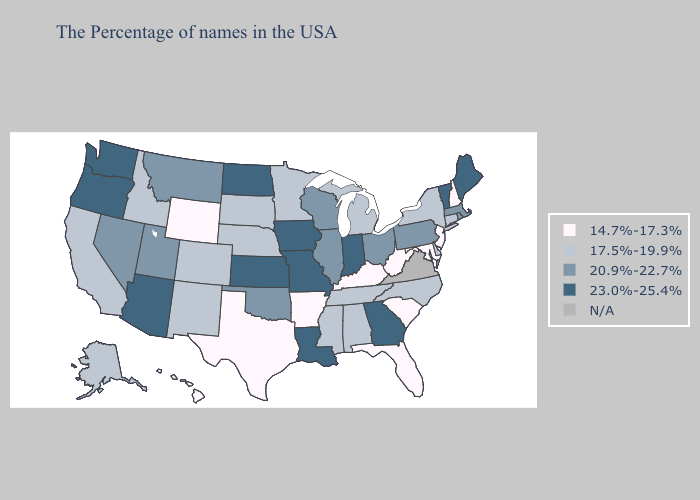Name the states that have a value in the range 14.7%-17.3%?
Concise answer only. New Hampshire, New Jersey, Maryland, South Carolina, West Virginia, Florida, Kentucky, Arkansas, Texas, Wyoming, Hawaii. Does Rhode Island have the highest value in the Northeast?
Answer briefly. No. Among the states that border Florida , does Alabama have the highest value?
Answer briefly. No. Name the states that have a value in the range 17.5%-19.9%?
Quick response, please. Connecticut, New York, Delaware, North Carolina, Michigan, Alabama, Tennessee, Mississippi, Minnesota, Nebraska, South Dakota, Colorado, New Mexico, Idaho, California, Alaska. How many symbols are there in the legend?
Short answer required. 5. Which states have the lowest value in the USA?
Be succinct. New Hampshire, New Jersey, Maryland, South Carolina, West Virginia, Florida, Kentucky, Arkansas, Texas, Wyoming, Hawaii. What is the highest value in the MidWest ?
Be succinct. 23.0%-25.4%. What is the highest value in the USA?
Short answer required. 23.0%-25.4%. What is the value of Connecticut?
Give a very brief answer. 17.5%-19.9%. Which states have the lowest value in the West?
Give a very brief answer. Wyoming, Hawaii. Is the legend a continuous bar?
Quick response, please. No. What is the value of South Dakota?
Short answer required. 17.5%-19.9%. Which states have the lowest value in the South?
Give a very brief answer. Maryland, South Carolina, West Virginia, Florida, Kentucky, Arkansas, Texas. Does Kansas have the lowest value in the USA?
Quick response, please. No. 